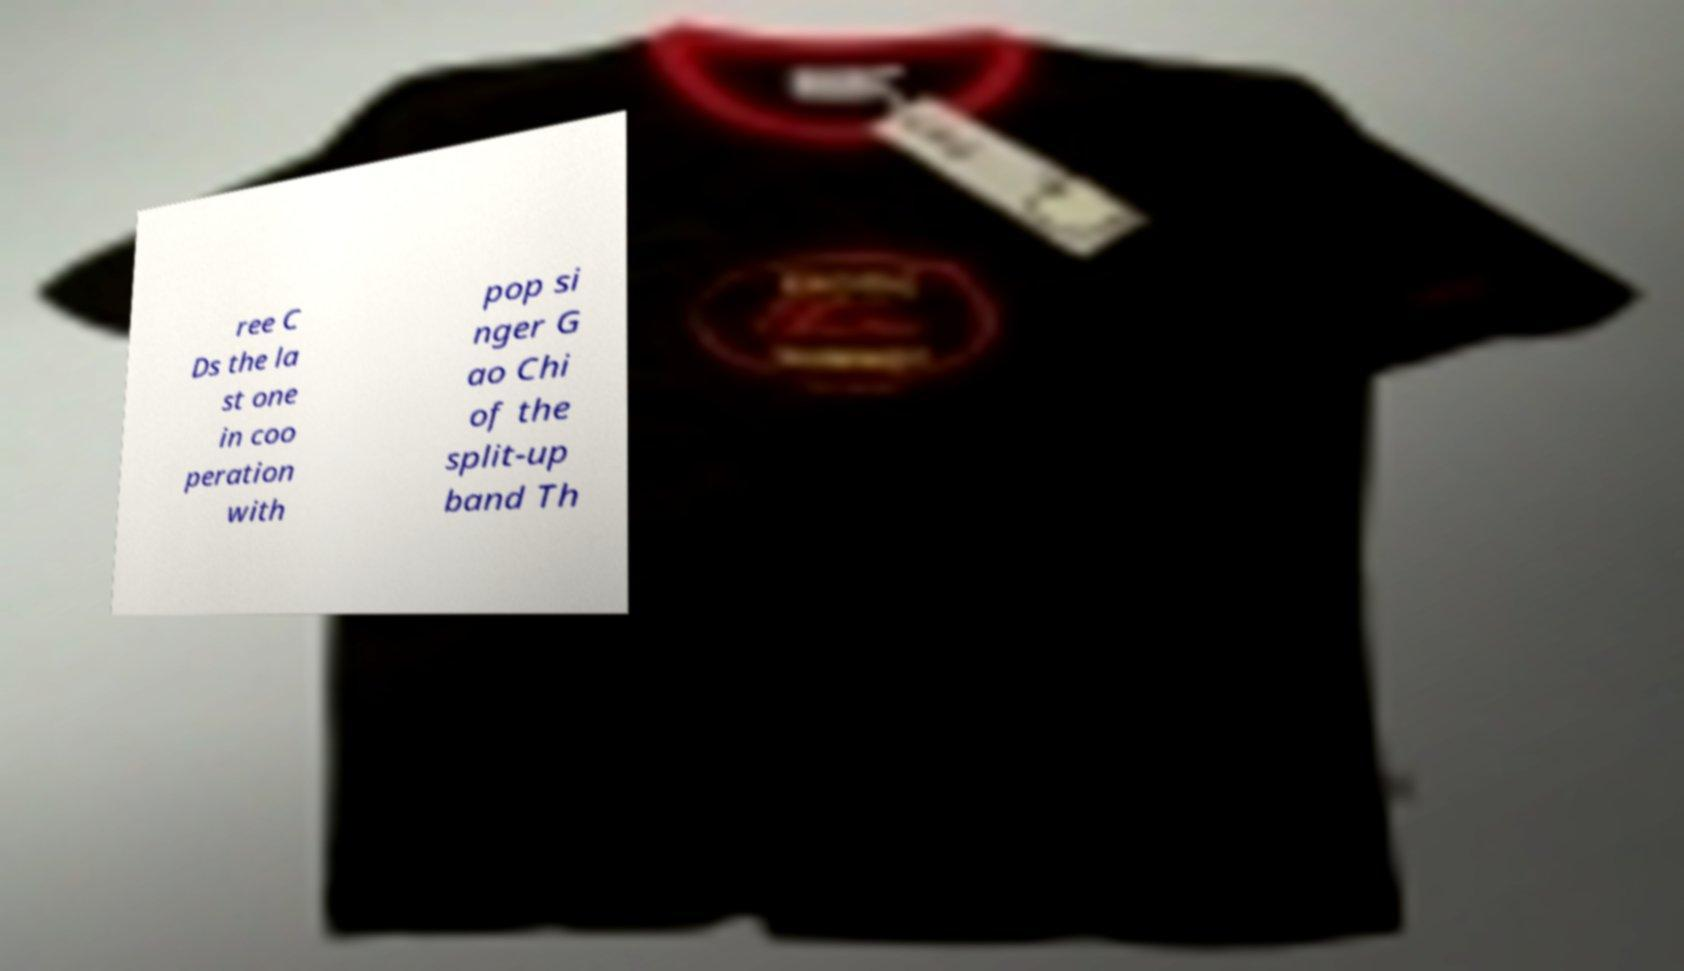There's text embedded in this image that I need extracted. Can you transcribe it verbatim? ree C Ds the la st one in coo peration with pop si nger G ao Chi of the split-up band Th 